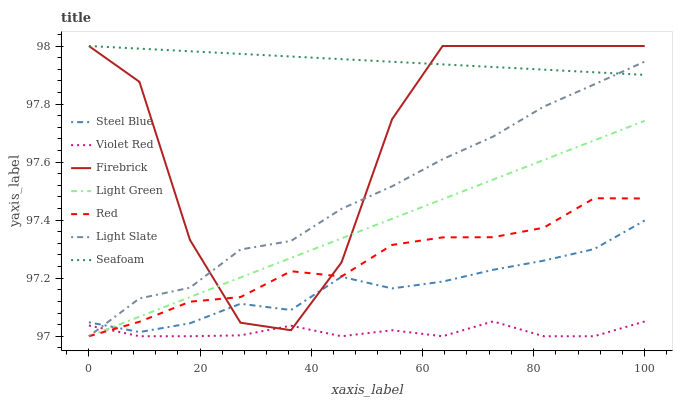Does Light Slate have the minimum area under the curve?
Answer yes or no. No. Does Light Slate have the maximum area under the curve?
Answer yes or no. No. Is Light Slate the smoothest?
Answer yes or no. No. Is Light Slate the roughest?
Answer yes or no. No. Does Firebrick have the lowest value?
Answer yes or no. No. Does Light Slate have the highest value?
Answer yes or no. No. Is Steel Blue less than Seafoam?
Answer yes or no. Yes. Is Seafoam greater than Red?
Answer yes or no. Yes. Does Steel Blue intersect Seafoam?
Answer yes or no. No. 